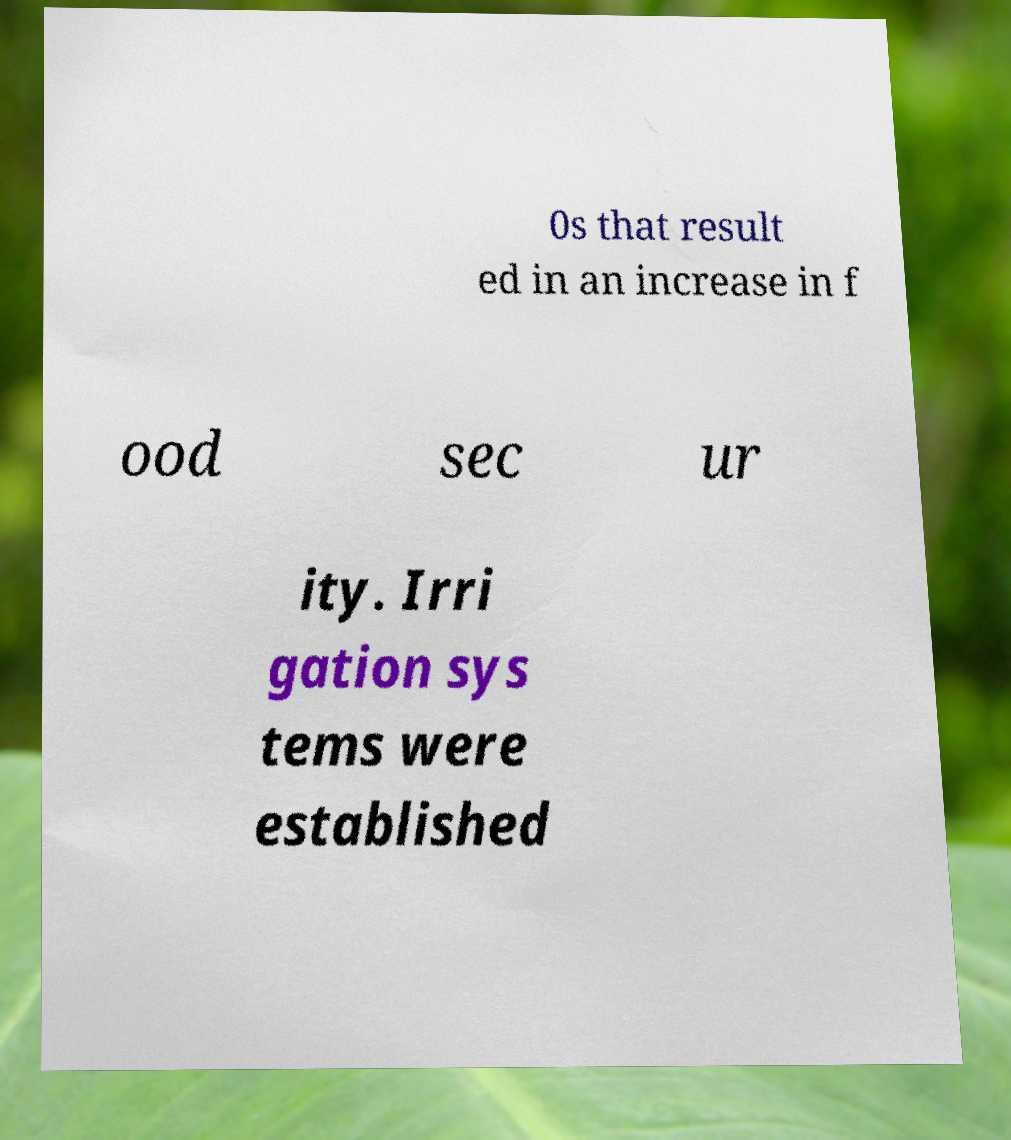There's text embedded in this image that I need extracted. Can you transcribe it verbatim? 0s that result ed in an increase in f ood sec ur ity. Irri gation sys tems were established 